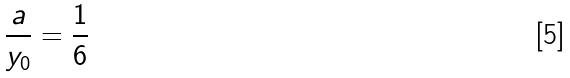<formula> <loc_0><loc_0><loc_500><loc_500>\frac { a } { y _ { 0 } } = \frac { 1 } { 6 }</formula> 